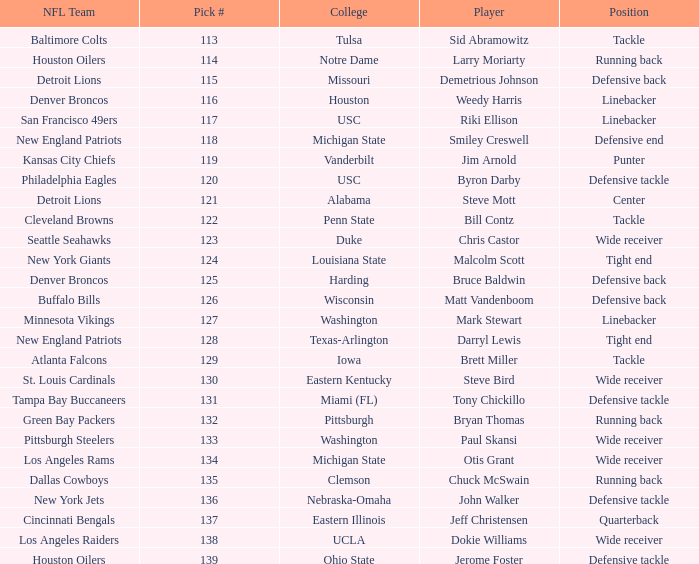What pick number did the buffalo bills get? 126.0. Write the full table. {'header': ['NFL Team', 'Pick #', 'College', 'Player', 'Position'], 'rows': [['Baltimore Colts', '113', 'Tulsa', 'Sid Abramowitz', 'Tackle'], ['Houston Oilers', '114', 'Notre Dame', 'Larry Moriarty', 'Running back'], ['Detroit Lions', '115', 'Missouri', 'Demetrious Johnson', 'Defensive back'], ['Denver Broncos', '116', 'Houston', 'Weedy Harris', 'Linebacker'], ['San Francisco 49ers', '117', 'USC', 'Riki Ellison', 'Linebacker'], ['New England Patriots', '118', 'Michigan State', 'Smiley Creswell', 'Defensive end'], ['Kansas City Chiefs', '119', 'Vanderbilt', 'Jim Arnold', 'Punter'], ['Philadelphia Eagles', '120', 'USC', 'Byron Darby', 'Defensive tackle'], ['Detroit Lions', '121', 'Alabama', 'Steve Mott', 'Center'], ['Cleveland Browns', '122', 'Penn State', 'Bill Contz', 'Tackle'], ['Seattle Seahawks', '123', 'Duke', 'Chris Castor', 'Wide receiver'], ['New York Giants', '124', 'Louisiana State', 'Malcolm Scott', 'Tight end'], ['Denver Broncos', '125', 'Harding', 'Bruce Baldwin', 'Defensive back'], ['Buffalo Bills', '126', 'Wisconsin', 'Matt Vandenboom', 'Defensive back'], ['Minnesota Vikings', '127', 'Washington', 'Mark Stewart', 'Linebacker'], ['New England Patriots', '128', 'Texas-Arlington', 'Darryl Lewis', 'Tight end'], ['Atlanta Falcons', '129', 'Iowa', 'Brett Miller', 'Tackle'], ['St. Louis Cardinals', '130', 'Eastern Kentucky', 'Steve Bird', 'Wide receiver'], ['Tampa Bay Buccaneers', '131', 'Miami (FL)', 'Tony Chickillo', 'Defensive tackle'], ['Green Bay Packers', '132', 'Pittsburgh', 'Bryan Thomas', 'Running back'], ['Pittsburgh Steelers', '133', 'Washington', 'Paul Skansi', 'Wide receiver'], ['Los Angeles Rams', '134', 'Michigan State', 'Otis Grant', 'Wide receiver'], ['Dallas Cowboys', '135', 'Clemson', 'Chuck McSwain', 'Running back'], ['New York Jets', '136', 'Nebraska-Omaha', 'John Walker', 'Defensive tackle'], ['Cincinnati Bengals', '137', 'Eastern Illinois', 'Jeff Christensen', 'Quarterback'], ['Los Angeles Raiders', '138', 'UCLA', 'Dokie Williams', 'Wide receiver'], ['Houston Oilers', '139', 'Ohio State', 'Jerome Foster', 'Defensive tackle']]} 